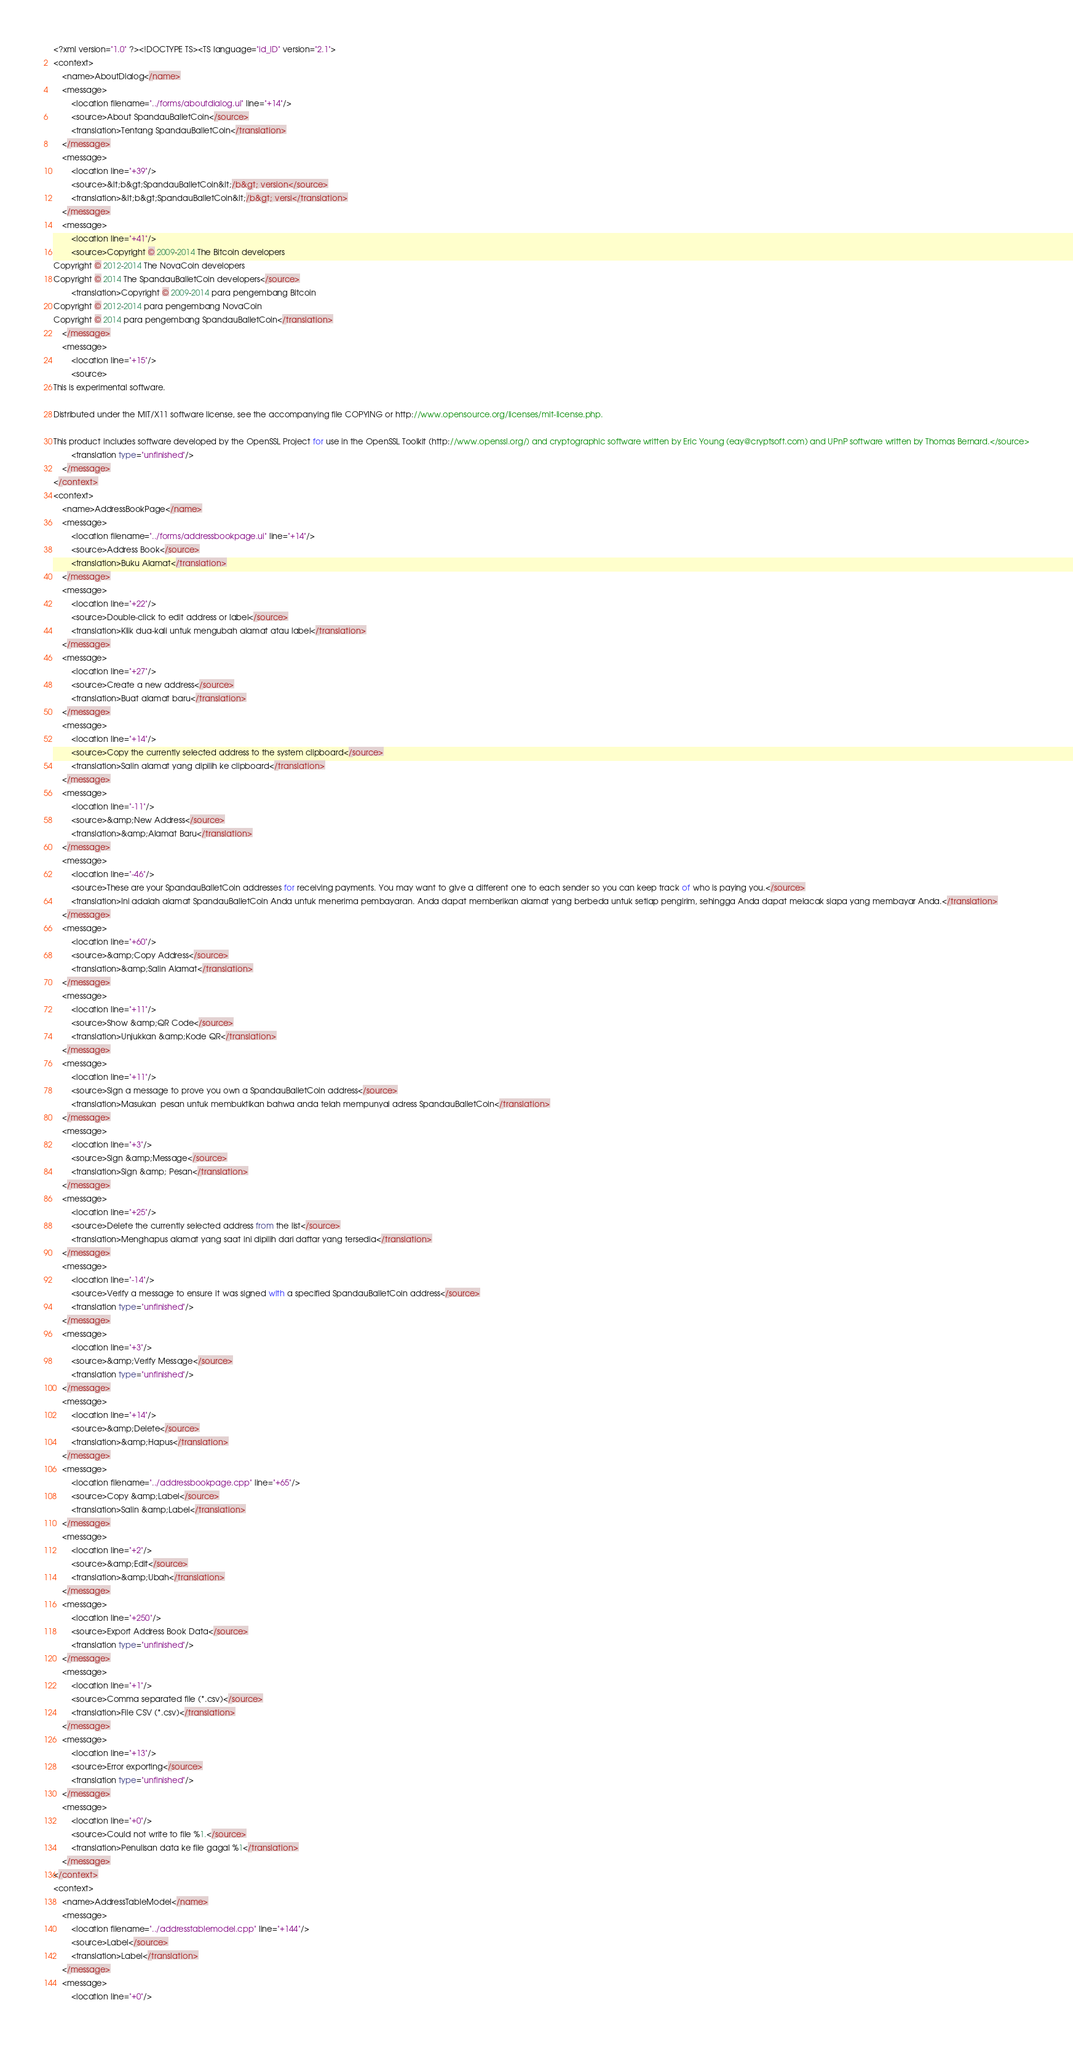<code> <loc_0><loc_0><loc_500><loc_500><_TypeScript_><?xml version="1.0" ?><!DOCTYPE TS><TS language="id_ID" version="2.1">
<context>
    <name>AboutDialog</name>
    <message>
        <location filename="../forms/aboutdialog.ui" line="+14"/>
        <source>About SpandauBalletCoin</source>
        <translation>Tentang SpandauBalletCoin</translation>
    </message>
    <message>
        <location line="+39"/>
        <source>&lt;b&gt;SpandauBalletCoin&lt;/b&gt; version</source>
        <translation>&lt;b&gt;SpandauBalletCoin&lt;/b&gt; versi</translation>
    </message>
    <message>
        <location line="+41"/>
        <source>Copyright © 2009-2014 The Bitcoin developers
Copyright © 2012-2014 The NovaCoin developers
Copyright © 2014 The SpandauBalletCoin developers</source>
        <translation>Copyright © 2009-2014 para pengembang Bitcoin
Copyright © 2012-2014 para pengembang NovaCoin
Copyright © 2014 para pengembang SpandauBalletCoin</translation>
    </message>
    <message>
        <location line="+15"/>
        <source>
This is experimental software.

Distributed under the MIT/X11 software license, see the accompanying file COPYING or http://www.opensource.org/licenses/mit-license.php.

This product includes software developed by the OpenSSL Project for use in the OpenSSL Toolkit (http://www.openssl.org/) and cryptographic software written by Eric Young (eay@cryptsoft.com) and UPnP software written by Thomas Bernard.</source>
        <translation type="unfinished"/>
    </message>
</context>
<context>
    <name>AddressBookPage</name>
    <message>
        <location filename="../forms/addressbookpage.ui" line="+14"/>
        <source>Address Book</source>
        <translation>Buku Alamat</translation>
    </message>
    <message>
        <location line="+22"/>
        <source>Double-click to edit address or label</source>
        <translation>Klik dua-kali untuk mengubah alamat atau label</translation>
    </message>
    <message>
        <location line="+27"/>
        <source>Create a new address</source>
        <translation>Buat alamat baru</translation>
    </message>
    <message>
        <location line="+14"/>
        <source>Copy the currently selected address to the system clipboard</source>
        <translation>Salin alamat yang dipilih ke clipboard</translation>
    </message>
    <message>
        <location line="-11"/>
        <source>&amp;New Address</source>
        <translation>&amp;Alamat Baru</translation>
    </message>
    <message>
        <location line="-46"/>
        <source>These are your SpandauBalletCoin addresses for receiving payments. You may want to give a different one to each sender so you can keep track of who is paying you.</source>
        <translation>Ini adalah alamat SpandauBalletCoin Anda untuk menerima pembayaran. Anda dapat memberikan alamat yang berbeda untuk setiap pengirim, sehingga Anda dapat melacak siapa yang membayar Anda.</translation>
    </message>
    <message>
        <location line="+60"/>
        <source>&amp;Copy Address</source>
        <translation>&amp;Salin Alamat</translation>
    </message>
    <message>
        <location line="+11"/>
        <source>Show &amp;QR Code</source>
        <translation>Unjukkan &amp;Kode QR</translation>
    </message>
    <message>
        <location line="+11"/>
        <source>Sign a message to prove you own a SpandauBalletCoin address</source>
        <translation>Masukan  pesan untuk membuktikan bahwa anda telah mempunyai adress SpandauBalletCoin</translation>
    </message>
    <message>
        <location line="+3"/>
        <source>Sign &amp;Message</source>
        <translation>Sign &amp; Pesan</translation>
    </message>
    <message>
        <location line="+25"/>
        <source>Delete the currently selected address from the list</source>
        <translation>Menghapus alamat yang saat ini dipilih dari daftar yang tersedia</translation>
    </message>
    <message>
        <location line="-14"/>
        <source>Verify a message to ensure it was signed with a specified SpandauBalletCoin address</source>
        <translation type="unfinished"/>
    </message>
    <message>
        <location line="+3"/>
        <source>&amp;Verify Message</source>
        <translation type="unfinished"/>
    </message>
    <message>
        <location line="+14"/>
        <source>&amp;Delete</source>
        <translation>&amp;Hapus</translation>
    </message>
    <message>
        <location filename="../addressbookpage.cpp" line="+65"/>
        <source>Copy &amp;Label</source>
        <translation>Salin &amp;Label</translation>
    </message>
    <message>
        <location line="+2"/>
        <source>&amp;Edit</source>
        <translation>&amp;Ubah</translation>
    </message>
    <message>
        <location line="+250"/>
        <source>Export Address Book Data</source>
        <translation type="unfinished"/>
    </message>
    <message>
        <location line="+1"/>
        <source>Comma separated file (*.csv)</source>
        <translation>File CSV (*.csv)</translation>
    </message>
    <message>
        <location line="+13"/>
        <source>Error exporting</source>
        <translation type="unfinished"/>
    </message>
    <message>
        <location line="+0"/>
        <source>Could not write to file %1.</source>
        <translation>Penulisan data ke file gagal %1</translation>
    </message>
</context>
<context>
    <name>AddressTableModel</name>
    <message>
        <location filename="../addresstablemodel.cpp" line="+144"/>
        <source>Label</source>
        <translation>Label</translation>
    </message>
    <message>
        <location line="+0"/></code> 